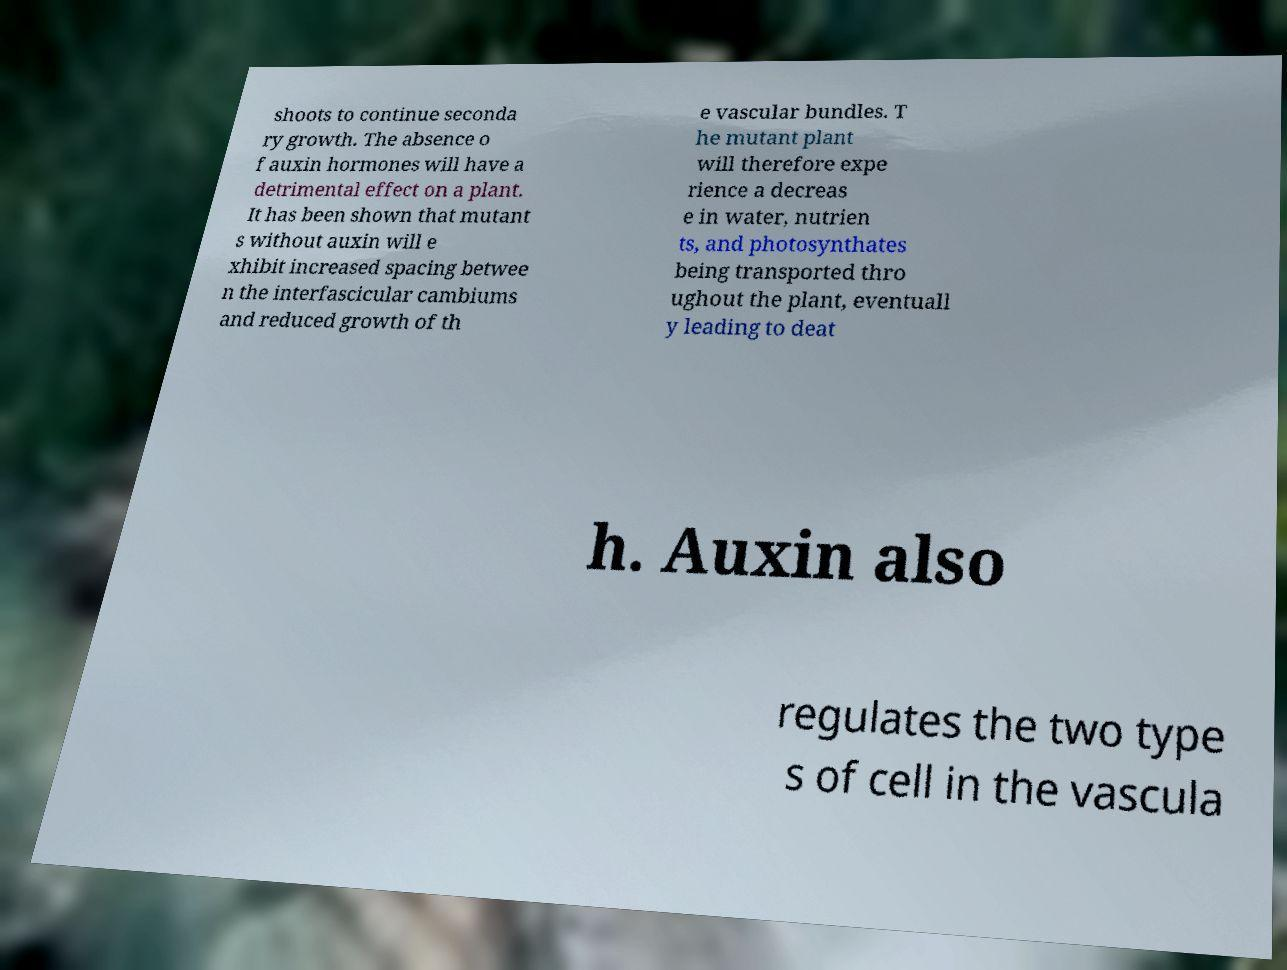Could you extract and type out the text from this image? shoots to continue seconda ry growth. The absence o f auxin hormones will have a detrimental effect on a plant. It has been shown that mutant s without auxin will e xhibit increased spacing betwee n the interfascicular cambiums and reduced growth of th e vascular bundles. T he mutant plant will therefore expe rience a decreas e in water, nutrien ts, and photosynthates being transported thro ughout the plant, eventuall y leading to deat h. Auxin also regulates the two type s of cell in the vascula 